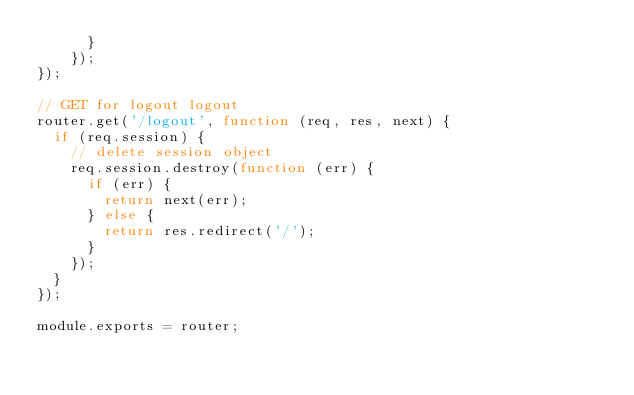<code> <loc_0><loc_0><loc_500><loc_500><_JavaScript_>      }
    });
});

// GET for logout logout
router.get('/logout', function (req, res, next) {
  if (req.session) {
    // delete session object
    req.session.destroy(function (err) {
      if (err) {
        return next(err);
      } else {
        return res.redirect('/');
      }
    });
  }
});

module.exports = router;</code> 